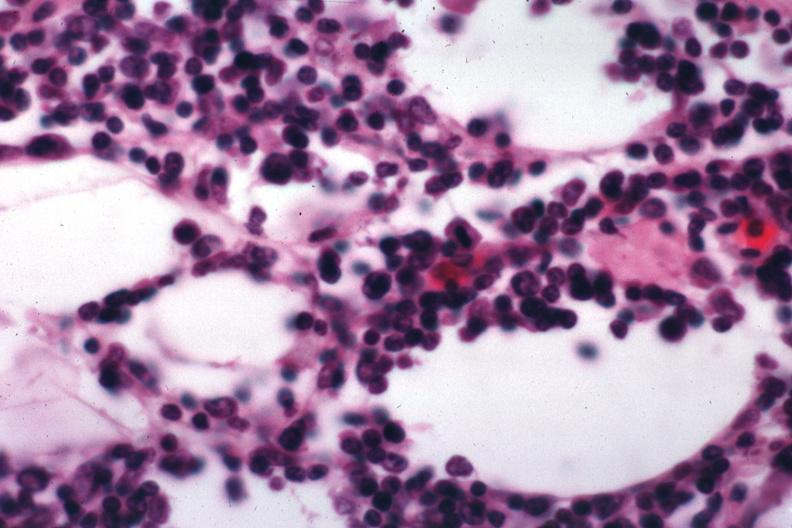what does this image show?
Answer the question using a single word or phrase. Lymphocytic infiltration in perinodal fat 